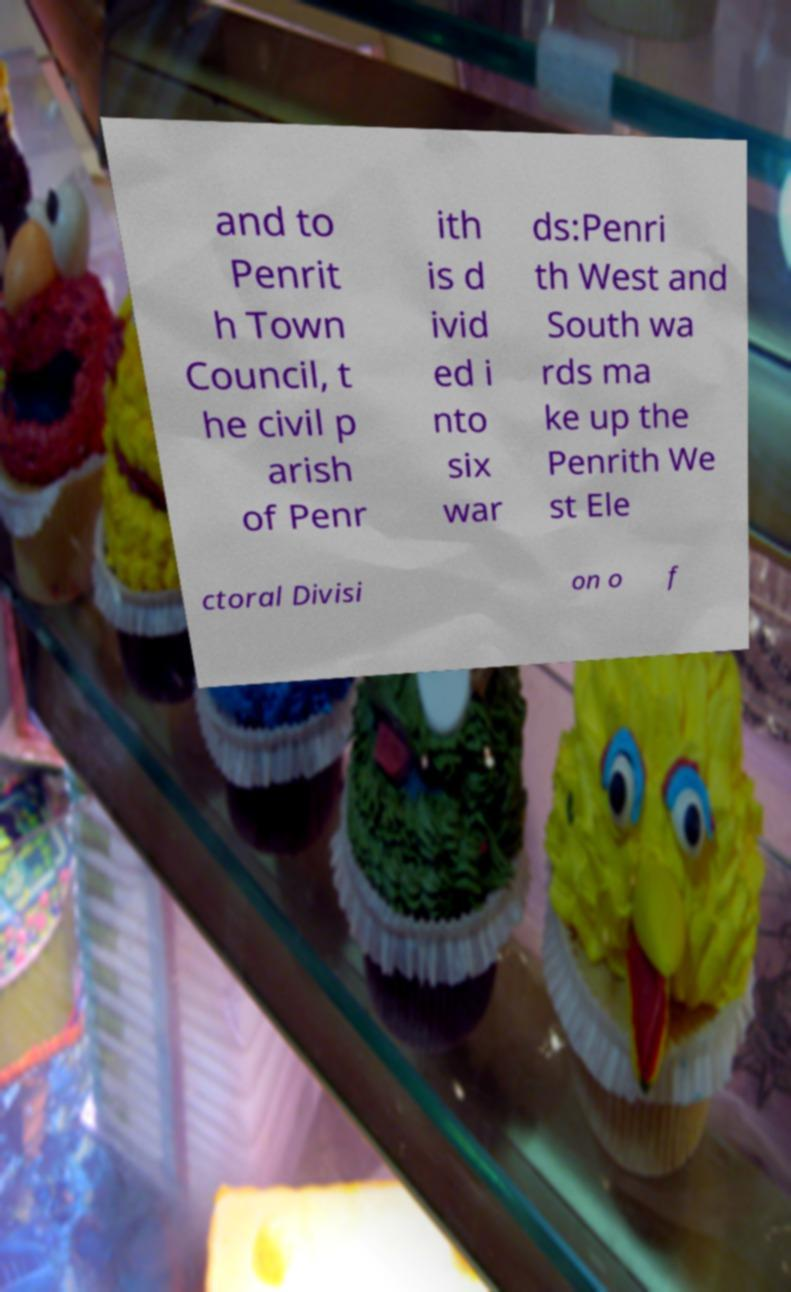Could you assist in decoding the text presented in this image and type it out clearly? and to Penrit h Town Council, t he civil p arish of Penr ith is d ivid ed i nto six war ds:Penri th West and South wa rds ma ke up the Penrith We st Ele ctoral Divisi on o f 